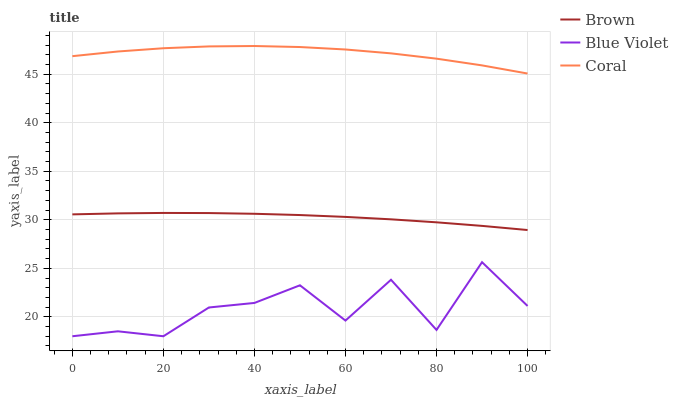Does Blue Violet have the minimum area under the curve?
Answer yes or no. Yes. Does Coral have the maximum area under the curve?
Answer yes or no. Yes. Does Coral have the minimum area under the curve?
Answer yes or no. No. Does Blue Violet have the maximum area under the curve?
Answer yes or no. No. Is Brown the smoothest?
Answer yes or no. Yes. Is Blue Violet the roughest?
Answer yes or no. Yes. Is Coral the smoothest?
Answer yes or no. No. Is Coral the roughest?
Answer yes or no. No. Does Coral have the lowest value?
Answer yes or no. No. Does Coral have the highest value?
Answer yes or no. Yes. Does Blue Violet have the highest value?
Answer yes or no. No. Is Brown less than Coral?
Answer yes or no. Yes. Is Coral greater than Brown?
Answer yes or no. Yes. Does Brown intersect Coral?
Answer yes or no. No. 